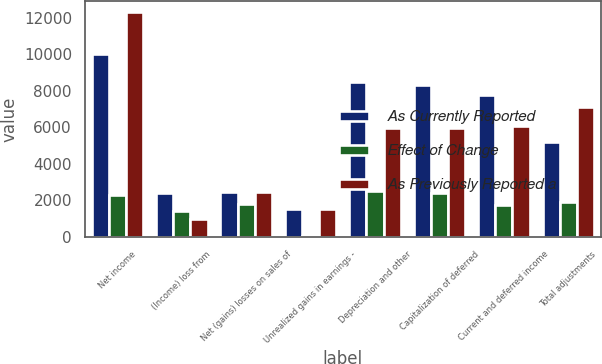<chart> <loc_0><loc_0><loc_500><loc_500><stacked_bar_chart><ecel><fcel>Net income<fcel>(Income) loss from<fcel>Net (gains) losses on sales of<fcel>Unrealized gains in earnings -<fcel>Depreciation and other<fcel>Capitalization of deferred<fcel>Current and deferred income<fcel>Total adjustments<nl><fcel>As Currently Reported<fcel>10013<fcel>2388<fcel>2449.5<fcel>1509<fcel>8488<fcel>8300<fcel>7780<fcel>5201<nl><fcel>Effect of Change<fcel>2272<fcel>1419<fcel>1799<fcel>20<fcel>2511<fcel>2367<fcel>1728<fcel>1892<nl><fcel>As Previously Reported a<fcel>12285<fcel>969<fcel>2449.5<fcel>1529<fcel>5977<fcel>5933<fcel>6052<fcel>7093<nl></chart> 